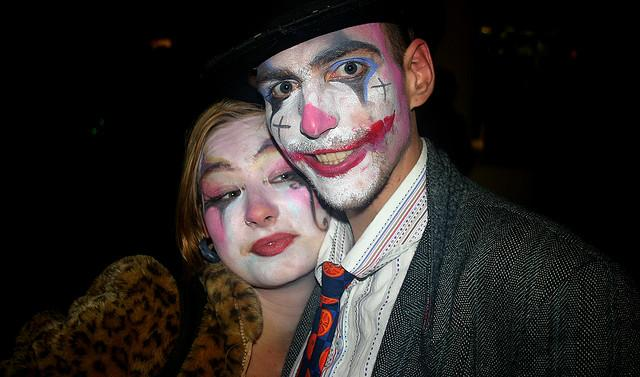What is the red thing near the man's mouth? makeup 